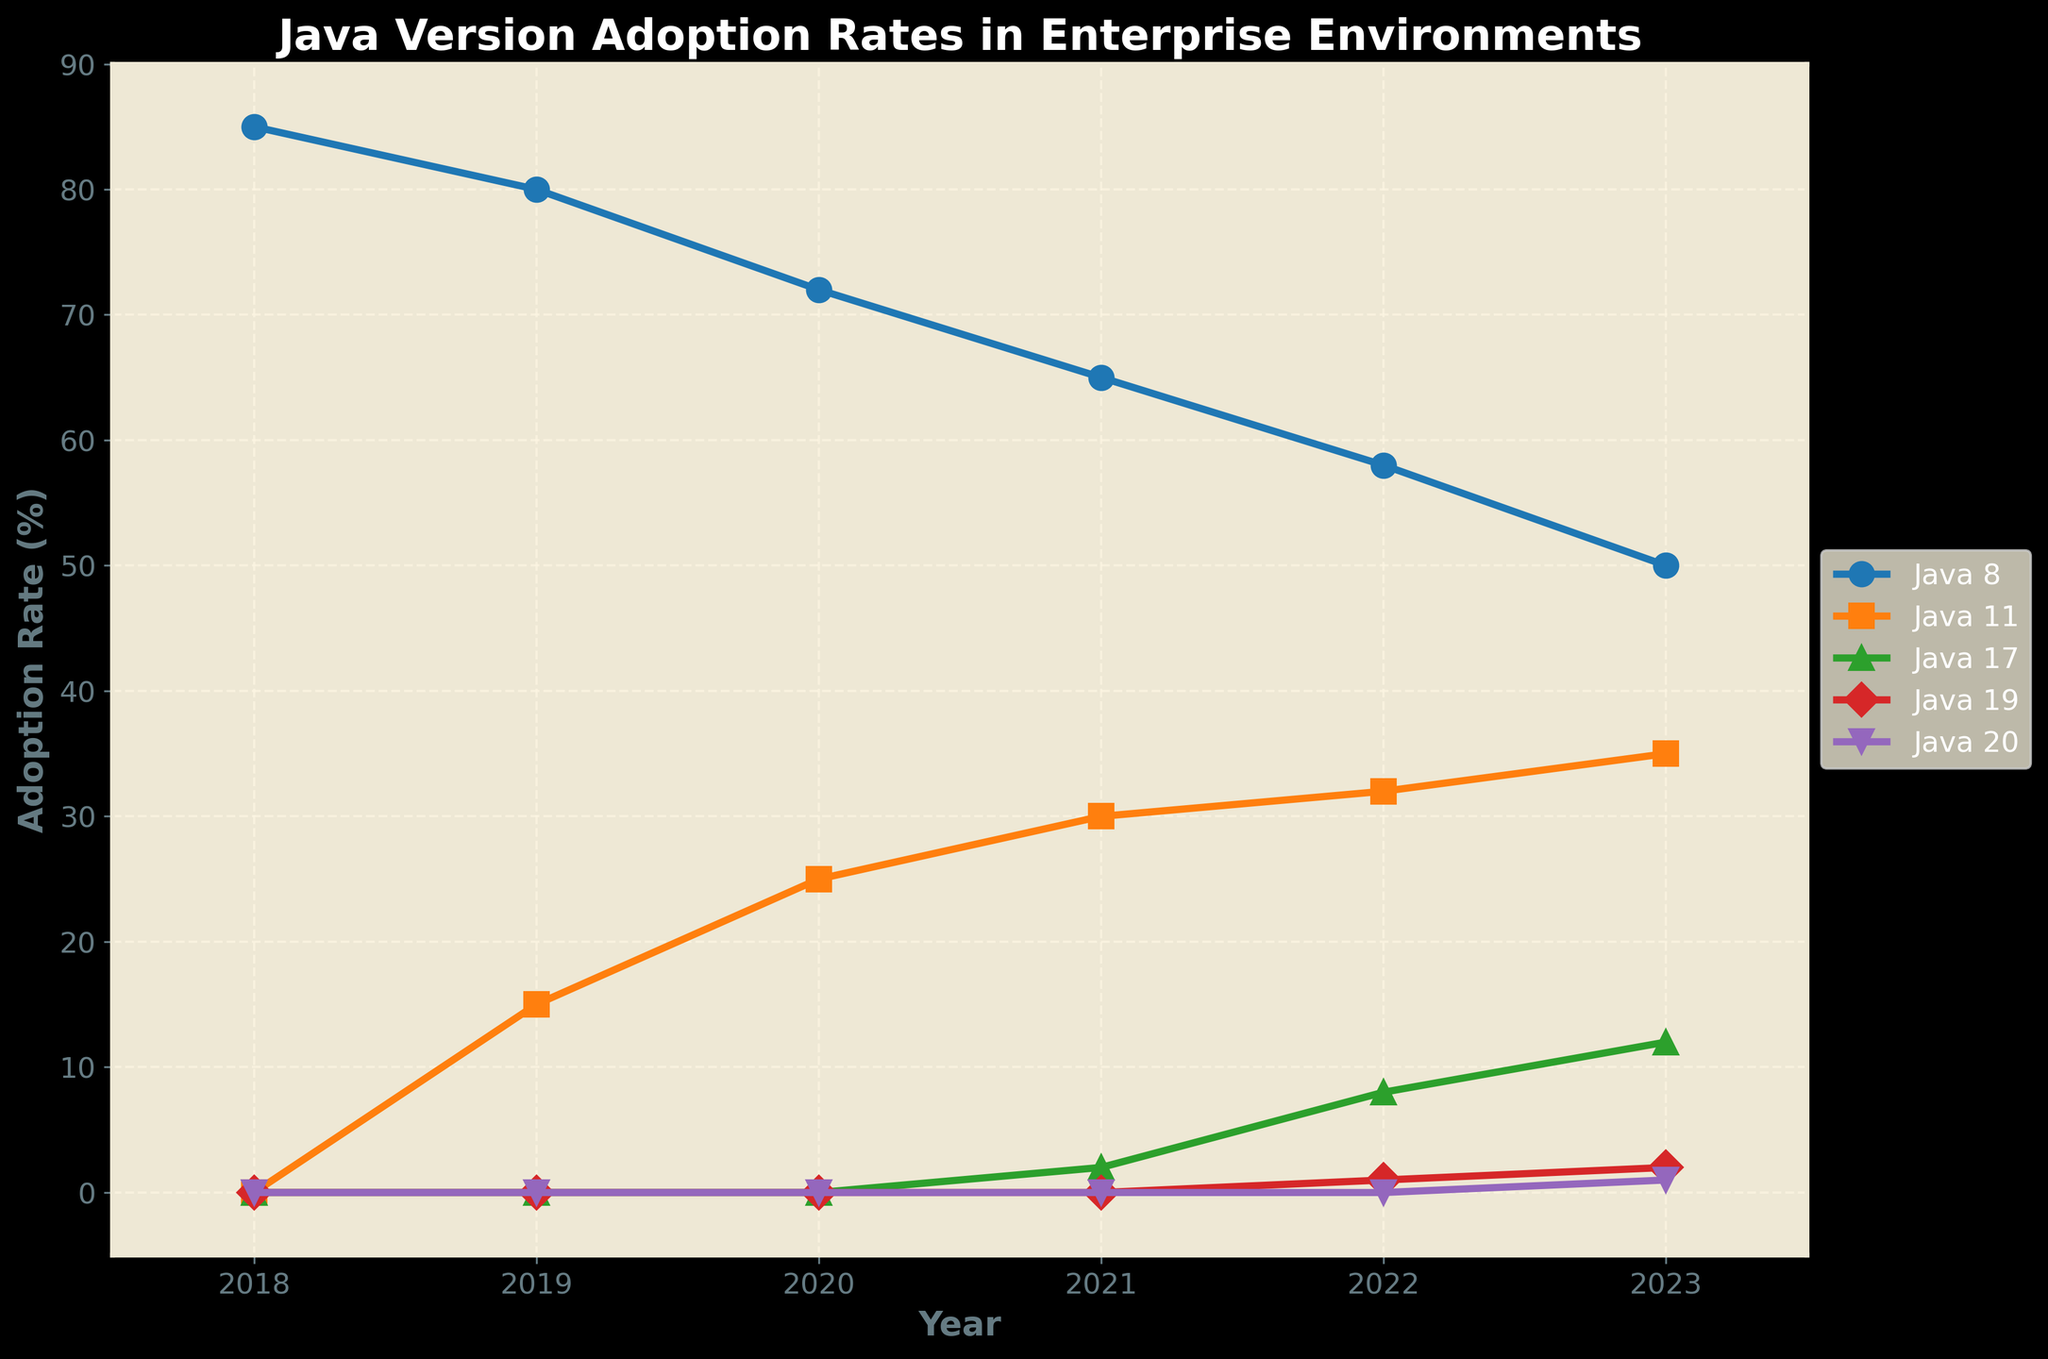What's the overall trend for Java 8 adoption from 2018 to 2023? The line for Java 8 shows a decreasing trend over the years. In 2018, the adoption rate was at 85%, and by 2023, it decreased to 50%. The trend shows a steady decline.
Answer: Decreasing Which Java version had its first noticeable adoption in 2021? From the plot, Java 17 had its first noticeable adoption in 2021, with an adoption rate of 2%.
Answer: Java 17 Between Java 8 and Java 11, which version had a higher adoption rate in 2020? By looking at the lines representing Java 8 and Java 11 in 2020, Java 8 had a higher adoption rate of 72%, while Java 11 had an adoption rate of 25%.
Answer: Java 8 In which year did Java 11 adoption rate first surpass 30%? From the chart, Java 11 adoption rate first surpassed 30% in 2021, where it reached 30%.
Answer: 2021 What’s the difference in adoption rates between Java 8 and Java 19 in 2022? In 2022, the adoption rate for Java 8 was 58%, and for Java 19, it was 1%. The difference between them is 58% - 1% = 57%.
Answer: 57% Which Java version showed the most significant increase in adoption rate from 2019 to 2020? Java 11 showed the most significant increase from 2019 to 2020, with an increase from 15% to 25%, i.e., 10 percentage points.
Answer: Java 11 What's the median adoption rate of Java 8 from 2018 to 2023? The adoption rates for Java 8 from 2018 to 2023 are 85%, 80%, 72%, 65%, 58%, 50%. Sorting these values: 50%, 58%, 65%, 72%, 80%, 85%. The median is the average of 65% and 72%, which is (65 + 72) / 2 = 68.5%.
Answer: 68.5% How many new Java versions had an adoption rate greater than 0% in 2023 compared to 2018? In 2018, only Java 8 had an adoption rate, while in 2023, Java 11, Java 17, Java 19, and Java 20 also had adoption rates greater than 0%. Thus, 4 new Java versions had an adoption rate > 0% in 2023.
Answer: 4 Which Java version has the slowest increase in adoption rate from its introduction to 2023? Java 19 showed the slowest increase in adoption rate, starting at 0% in its introduction in 2022 and reaching only 2% by 2023.
Answer: Java 19 